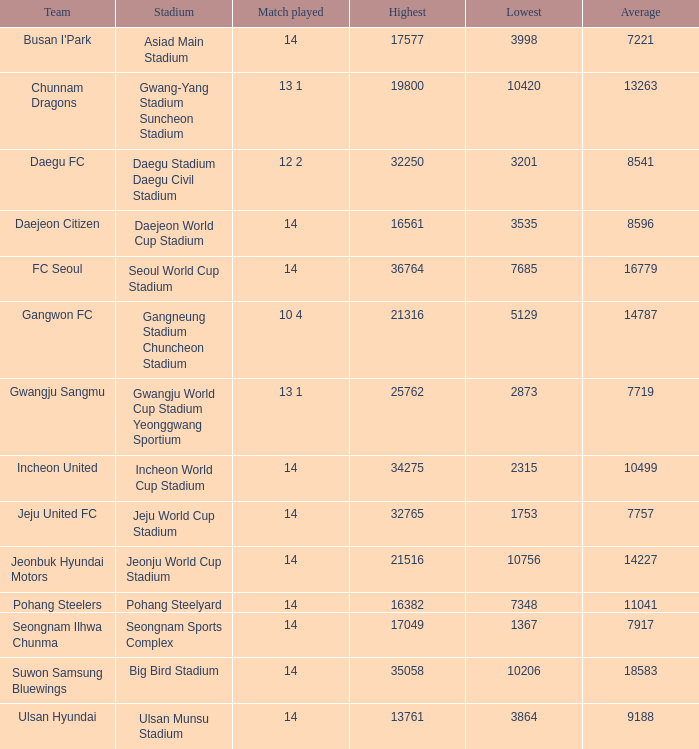Which team has 7757 as the average? Jeju United FC. 